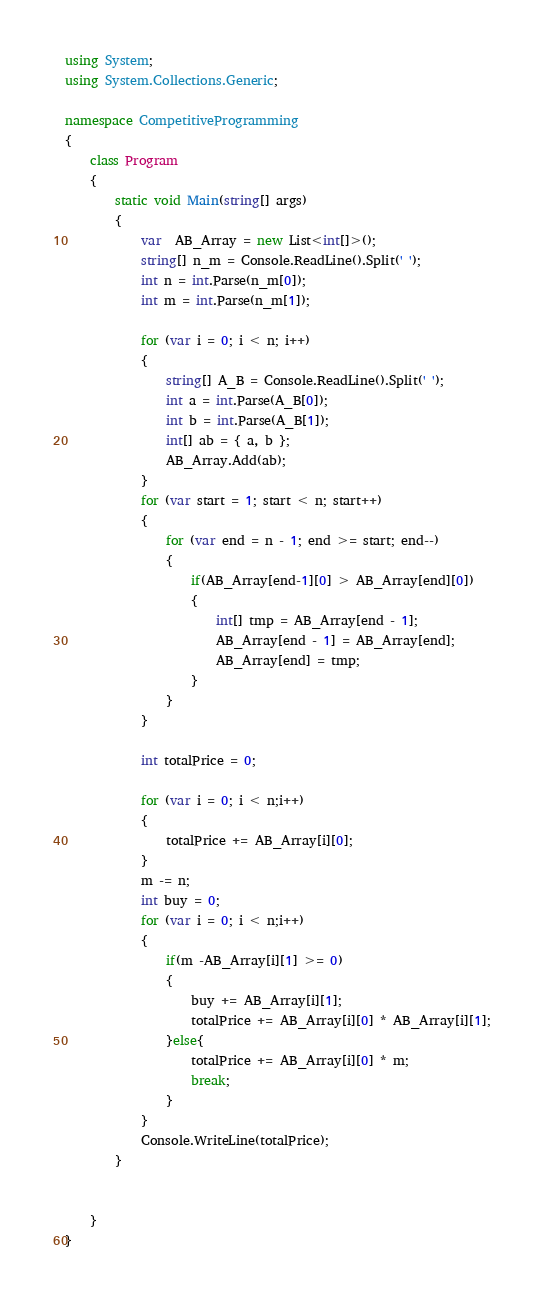<code> <loc_0><loc_0><loc_500><loc_500><_C#_>using System;
using System.Collections.Generic;

namespace CompetitiveProgramming
{
    class Program
    {
        static void Main(string[] args)
        {
            var  AB_Array = new List<int[]>();
            string[] n_m = Console.ReadLine().Split(' ');
            int n = int.Parse(n_m[0]);
            int m = int.Parse(n_m[1]);

            for (var i = 0; i < n; i++)
            {
                string[] A_B = Console.ReadLine().Split(' ');
                int a = int.Parse(A_B[0]);
                int b = int.Parse(A_B[1]);
                int[] ab = { a, b };
                AB_Array.Add(ab);
            }
            for (var start = 1; start < n; start++)
            {
                for (var end = n - 1; end >= start; end--)
                {
                    if(AB_Array[end-1][0] > AB_Array[end][0])
                    {
                        int[] tmp = AB_Array[end - 1];
                        AB_Array[end - 1] = AB_Array[end];
                        AB_Array[end] = tmp;
                    }
                }
            }

            int totalPrice = 0;

            for (var i = 0; i < n;i++)
            {
                totalPrice += AB_Array[i][0];
            }
            m -= n;
            int buy = 0;
            for (var i = 0; i < n;i++)
            {
                if(m -AB_Array[i][1] >= 0)
                {
                    buy += AB_Array[i][1];
                    totalPrice += AB_Array[i][0] * AB_Array[i][1];
                }else{
                    totalPrice += AB_Array[i][0] * m;
                    break;
                }
            }
            Console.WriteLine(totalPrice);
        }


    }
}
</code> 